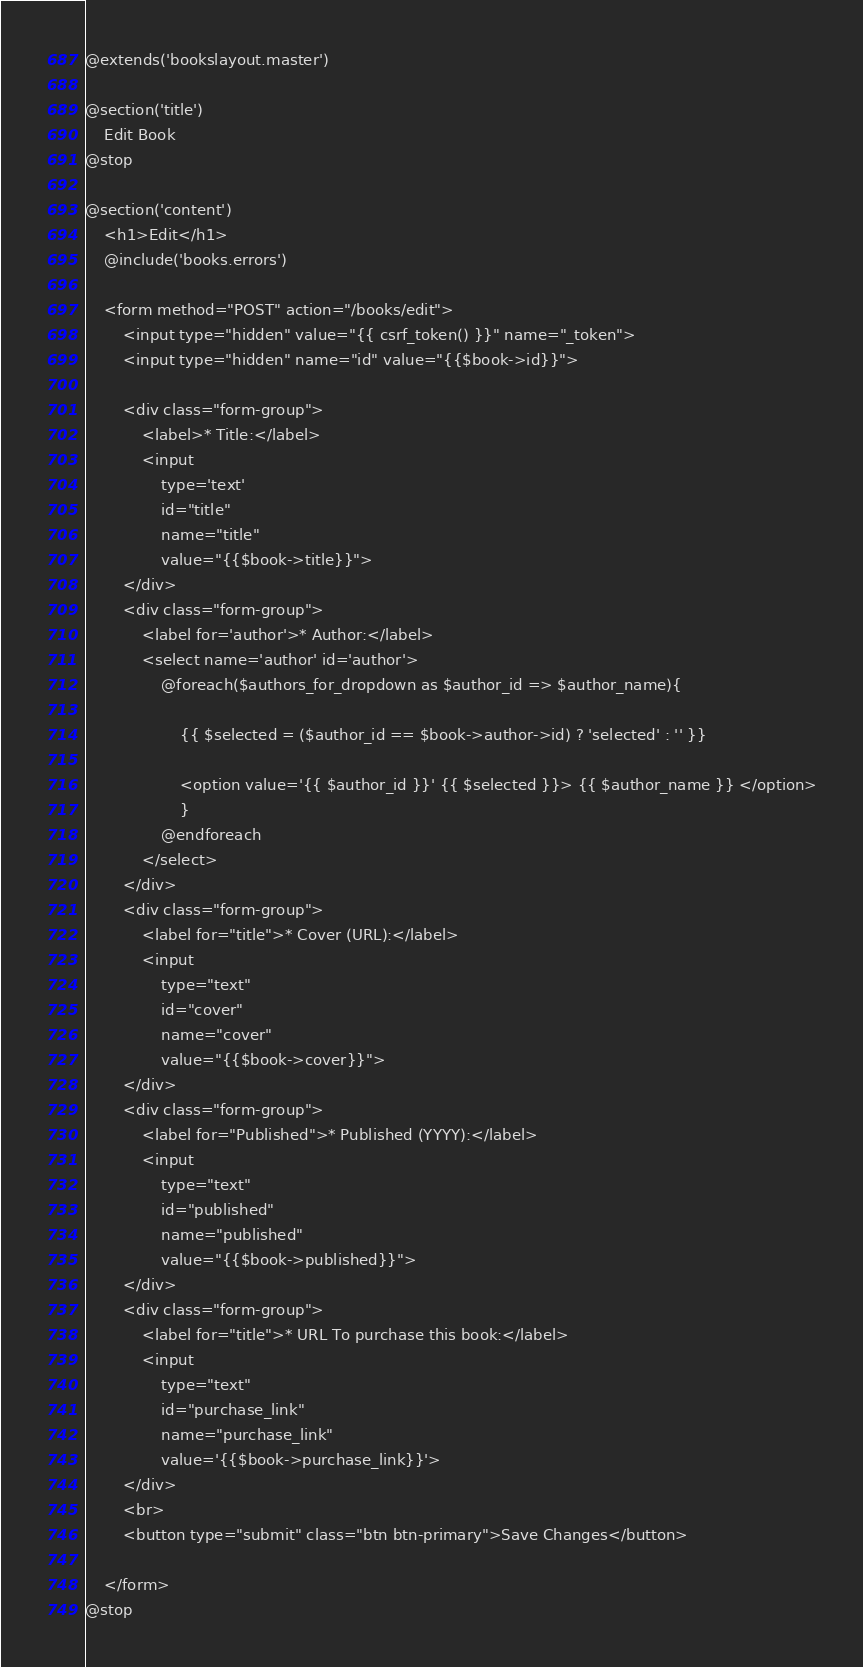<code> <loc_0><loc_0><loc_500><loc_500><_PHP_>@extends('bookslayout.master')

@section('title')
    Edit Book
@stop

@section('content')
    <h1>Edit</h1>
    @include('books.errors')

    <form method="POST" action="/books/edit">
        <input type="hidden" value="{{ csrf_token() }}" name="_token">
        <input type="hidden" name="id" value="{{$book->id}}">

        <div class="form-group">
            <label>* Title:</label>
            <input
                type='text'
                id="title"
                name="title"
                value="{{$book->title}}">
        </div>
        <div class="form-group">
            <label for='author'>* Author:</label>
            <select name='author' id='author'>
                @foreach($authors_for_dropdown as $author_id => $author_name){

                    {{ $selected = ($author_id == $book->author->id) ? 'selected' : '' }}

                    <option value='{{ $author_id }}' {{ $selected }}> {{ $author_name }} </option>
                    }
                @endforeach
            </select>
        </div>
        <div class="form-group">
            <label for="title">* Cover (URL):</label>
            <input
                type="text"
                id="cover"
                name="cover"
                value="{{$book->cover}}">
        </div>
        <div class="form-group">
            <label for="Published">* Published (YYYY):</label>
            <input
                type="text"
                id="published"
                name="published"
                value="{{$book->published}}">
        </div>
        <div class="form-group">
            <label for="title">* URL To purchase this book:</label>
            <input
                type="text"
                id="purchase_link"
                name="purchase_link"
                value='{{$book->purchase_link}}'>
        </div>
        <br>
        <button type="submit" class="btn btn-primary">Save Changes</button>

    </form>
@stop</code> 